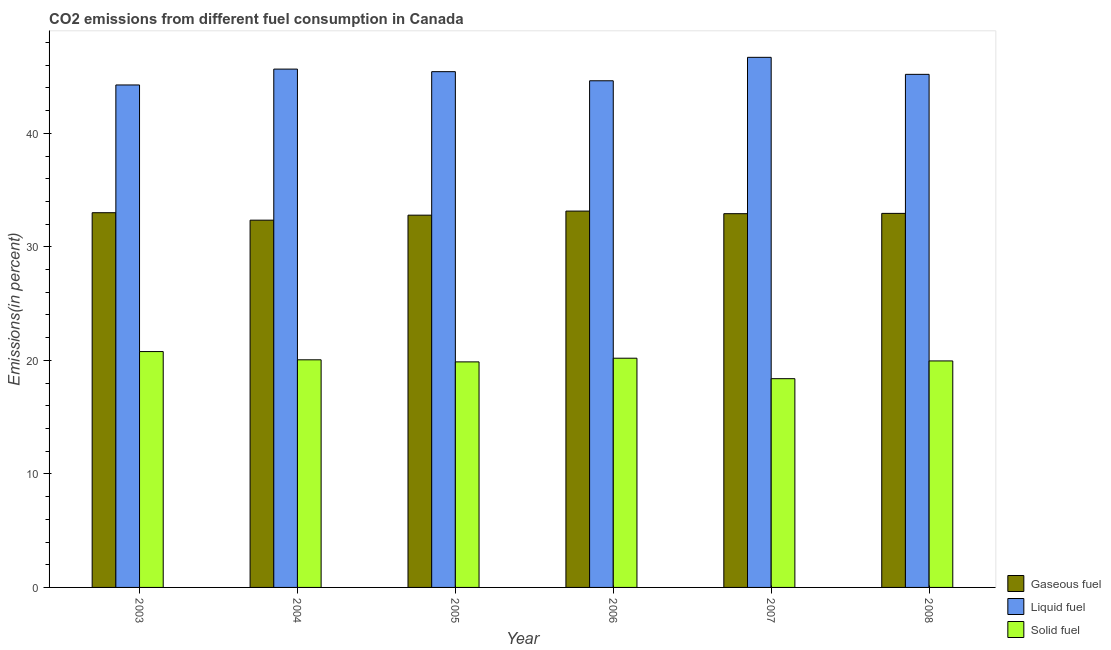How many groups of bars are there?
Ensure brevity in your answer.  6. How many bars are there on the 4th tick from the right?
Your answer should be compact. 3. What is the label of the 3rd group of bars from the left?
Ensure brevity in your answer.  2005. In how many cases, is the number of bars for a given year not equal to the number of legend labels?
Keep it short and to the point. 0. What is the percentage of liquid fuel emission in 2006?
Keep it short and to the point. 44.63. Across all years, what is the maximum percentage of liquid fuel emission?
Your answer should be compact. 46.7. Across all years, what is the minimum percentage of liquid fuel emission?
Your answer should be very brief. 44.26. In which year was the percentage of solid fuel emission minimum?
Your response must be concise. 2007. What is the total percentage of solid fuel emission in the graph?
Ensure brevity in your answer.  119.23. What is the difference between the percentage of gaseous fuel emission in 2007 and that in 2008?
Make the answer very short. -0.03. What is the difference between the percentage of liquid fuel emission in 2008 and the percentage of solid fuel emission in 2005?
Provide a succinct answer. -0.24. What is the average percentage of liquid fuel emission per year?
Your response must be concise. 45.32. What is the ratio of the percentage of liquid fuel emission in 2006 to that in 2007?
Give a very brief answer. 0.96. Is the percentage of liquid fuel emission in 2006 less than that in 2008?
Offer a very short reply. Yes. What is the difference between the highest and the second highest percentage of solid fuel emission?
Your answer should be very brief. 0.58. What is the difference between the highest and the lowest percentage of gaseous fuel emission?
Your answer should be very brief. 0.8. Is the sum of the percentage of liquid fuel emission in 2007 and 2008 greater than the maximum percentage of solid fuel emission across all years?
Offer a terse response. Yes. What does the 2nd bar from the left in 2004 represents?
Your answer should be compact. Liquid fuel. What does the 2nd bar from the right in 2006 represents?
Provide a short and direct response. Liquid fuel. Is it the case that in every year, the sum of the percentage of gaseous fuel emission and percentage of liquid fuel emission is greater than the percentage of solid fuel emission?
Give a very brief answer. Yes. Are all the bars in the graph horizontal?
Keep it short and to the point. No. Where does the legend appear in the graph?
Your response must be concise. Bottom right. How are the legend labels stacked?
Keep it short and to the point. Vertical. What is the title of the graph?
Give a very brief answer. CO2 emissions from different fuel consumption in Canada. Does "Social Protection" appear as one of the legend labels in the graph?
Your answer should be compact. No. What is the label or title of the Y-axis?
Offer a terse response. Emissions(in percent). What is the Emissions(in percent) in Gaseous fuel in 2003?
Give a very brief answer. 33.01. What is the Emissions(in percent) in Liquid fuel in 2003?
Provide a short and direct response. 44.26. What is the Emissions(in percent) of Solid fuel in 2003?
Ensure brevity in your answer.  20.78. What is the Emissions(in percent) in Gaseous fuel in 2004?
Offer a terse response. 32.35. What is the Emissions(in percent) in Liquid fuel in 2004?
Make the answer very short. 45.66. What is the Emissions(in percent) of Solid fuel in 2004?
Keep it short and to the point. 20.05. What is the Emissions(in percent) in Gaseous fuel in 2005?
Offer a terse response. 32.79. What is the Emissions(in percent) in Liquid fuel in 2005?
Give a very brief answer. 45.44. What is the Emissions(in percent) in Solid fuel in 2005?
Keep it short and to the point. 19.87. What is the Emissions(in percent) of Gaseous fuel in 2006?
Your answer should be compact. 33.15. What is the Emissions(in percent) in Liquid fuel in 2006?
Your answer should be very brief. 44.63. What is the Emissions(in percent) in Solid fuel in 2006?
Your answer should be very brief. 20.19. What is the Emissions(in percent) in Gaseous fuel in 2007?
Ensure brevity in your answer.  32.92. What is the Emissions(in percent) of Liquid fuel in 2007?
Your response must be concise. 46.7. What is the Emissions(in percent) of Solid fuel in 2007?
Your answer should be compact. 18.39. What is the Emissions(in percent) in Gaseous fuel in 2008?
Provide a succinct answer. 32.95. What is the Emissions(in percent) in Liquid fuel in 2008?
Your response must be concise. 45.2. What is the Emissions(in percent) of Solid fuel in 2008?
Make the answer very short. 19.95. Across all years, what is the maximum Emissions(in percent) of Gaseous fuel?
Your answer should be very brief. 33.15. Across all years, what is the maximum Emissions(in percent) in Liquid fuel?
Your answer should be very brief. 46.7. Across all years, what is the maximum Emissions(in percent) in Solid fuel?
Offer a terse response. 20.78. Across all years, what is the minimum Emissions(in percent) of Gaseous fuel?
Make the answer very short. 32.35. Across all years, what is the minimum Emissions(in percent) of Liquid fuel?
Your answer should be compact. 44.26. Across all years, what is the minimum Emissions(in percent) of Solid fuel?
Provide a succinct answer. 18.39. What is the total Emissions(in percent) in Gaseous fuel in the graph?
Provide a short and direct response. 197.19. What is the total Emissions(in percent) of Liquid fuel in the graph?
Your answer should be very brief. 271.89. What is the total Emissions(in percent) of Solid fuel in the graph?
Make the answer very short. 119.23. What is the difference between the Emissions(in percent) of Gaseous fuel in 2003 and that in 2004?
Offer a very short reply. 0.66. What is the difference between the Emissions(in percent) of Liquid fuel in 2003 and that in 2004?
Provide a succinct answer. -1.4. What is the difference between the Emissions(in percent) of Solid fuel in 2003 and that in 2004?
Provide a short and direct response. 0.73. What is the difference between the Emissions(in percent) of Gaseous fuel in 2003 and that in 2005?
Offer a very short reply. 0.22. What is the difference between the Emissions(in percent) of Liquid fuel in 2003 and that in 2005?
Your response must be concise. -1.17. What is the difference between the Emissions(in percent) in Solid fuel in 2003 and that in 2005?
Offer a very short reply. 0.91. What is the difference between the Emissions(in percent) in Gaseous fuel in 2003 and that in 2006?
Your response must be concise. -0.14. What is the difference between the Emissions(in percent) of Liquid fuel in 2003 and that in 2006?
Give a very brief answer. -0.37. What is the difference between the Emissions(in percent) in Solid fuel in 2003 and that in 2006?
Offer a terse response. 0.58. What is the difference between the Emissions(in percent) of Gaseous fuel in 2003 and that in 2007?
Your answer should be compact. 0.09. What is the difference between the Emissions(in percent) of Liquid fuel in 2003 and that in 2007?
Provide a short and direct response. -2.43. What is the difference between the Emissions(in percent) in Solid fuel in 2003 and that in 2007?
Ensure brevity in your answer.  2.39. What is the difference between the Emissions(in percent) of Gaseous fuel in 2003 and that in 2008?
Offer a very short reply. 0.06. What is the difference between the Emissions(in percent) in Liquid fuel in 2003 and that in 2008?
Provide a short and direct response. -0.93. What is the difference between the Emissions(in percent) of Solid fuel in 2003 and that in 2008?
Offer a terse response. 0.82. What is the difference between the Emissions(in percent) in Gaseous fuel in 2004 and that in 2005?
Make the answer very short. -0.44. What is the difference between the Emissions(in percent) of Liquid fuel in 2004 and that in 2005?
Your response must be concise. 0.23. What is the difference between the Emissions(in percent) in Solid fuel in 2004 and that in 2005?
Ensure brevity in your answer.  0.18. What is the difference between the Emissions(in percent) of Gaseous fuel in 2004 and that in 2006?
Your answer should be compact. -0.8. What is the difference between the Emissions(in percent) in Liquid fuel in 2004 and that in 2006?
Your response must be concise. 1.03. What is the difference between the Emissions(in percent) of Solid fuel in 2004 and that in 2006?
Your answer should be compact. -0.14. What is the difference between the Emissions(in percent) of Gaseous fuel in 2004 and that in 2007?
Keep it short and to the point. -0.57. What is the difference between the Emissions(in percent) of Liquid fuel in 2004 and that in 2007?
Your answer should be very brief. -1.04. What is the difference between the Emissions(in percent) in Solid fuel in 2004 and that in 2007?
Your answer should be compact. 1.66. What is the difference between the Emissions(in percent) in Gaseous fuel in 2004 and that in 2008?
Keep it short and to the point. -0.6. What is the difference between the Emissions(in percent) of Liquid fuel in 2004 and that in 2008?
Offer a very short reply. 0.46. What is the difference between the Emissions(in percent) of Solid fuel in 2004 and that in 2008?
Your response must be concise. 0.1. What is the difference between the Emissions(in percent) in Gaseous fuel in 2005 and that in 2006?
Provide a succinct answer. -0.36. What is the difference between the Emissions(in percent) of Liquid fuel in 2005 and that in 2006?
Keep it short and to the point. 0.8. What is the difference between the Emissions(in percent) in Solid fuel in 2005 and that in 2006?
Offer a very short reply. -0.32. What is the difference between the Emissions(in percent) of Gaseous fuel in 2005 and that in 2007?
Ensure brevity in your answer.  -0.13. What is the difference between the Emissions(in percent) in Liquid fuel in 2005 and that in 2007?
Provide a short and direct response. -1.26. What is the difference between the Emissions(in percent) in Solid fuel in 2005 and that in 2007?
Offer a terse response. 1.48. What is the difference between the Emissions(in percent) in Gaseous fuel in 2005 and that in 2008?
Give a very brief answer. -0.16. What is the difference between the Emissions(in percent) in Liquid fuel in 2005 and that in 2008?
Your answer should be very brief. 0.24. What is the difference between the Emissions(in percent) in Solid fuel in 2005 and that in 2008?
Give a very brief answer. -0.08. What is the difference between the Emissions(in percent) of Gaseous fuel in 2006 and that in 2007?
Ensure brevity in your answer.  0.23. What is the difference between the Emissions(in percent) of Liquid fuel in 2006 and that in 2007?
Make the answer very short. -2.07. What is the difference between the Emissions(in percent) of Solid fuel in 2006 and that in 2007?
Your answer should be very brief. 1.8. What is the difference between the Emissions(in percent) in Gaseous fuel in 2006 and that in 2008?
Make the answer very short. 0.2. What is the difference between the Emissions(in percent) in Liquid fuel in 2006 and that in 2008?
Ensure brevity in your answer.  -0.57. What is the difference between the Emissions(in percent) of Solid fuel in 2006 and that in 2008?
Offer a very short reply. 0.24. What is the difference between the Emissions(in percent) in Gaseous fuel in 2007 and that in 2008?
Your answer should be compact. -0.03. What is the difference between the Emissions(in percent) of Liquid fuel in 2007 and that in 2008?
Your answer should be very brief. 1.5. What is the difference between the Emissions(in percent) in Solid fuel in 2007 and that in 2008?
Offer a very short reply. -1.56. What is the difference between the Emissions(in percent) in Gaseous fuel in 2003 and the Emissions(in percent) in Liquid fuel in 2004?
Make the answer very short. -12.65. What is the difference between the Emissions(in percent) of Gaseous fuel in 2003 and the Emissions(in percent) of Solid fuel in 2004?
Provide a short and direct response. 12.96. What is the difference between the Emissions(in percent) in Liquid fuel in 2003 and the Emissions(in percent) in Solid fuel in 2004?
Offer a terse response. 24.21. What is the difference between the Emissions(in percent) in Gaseous fuel in 2003 and the Emissions(in percent) in Liquid fuel in 2005?
Make the answer very short. -12.43. What is the difference between the Emissions(in percent) of Gaseous fuel in 2003 and the Emissions(in percent) of Solid fuel in 2005?
Make the answer very short. 13.14. What is the difference between the Emissions(in percent) of Liquid fuel in 2003 and the Emissions(in percent) of Solid fuel in 2005?
Ensure brevity in your answer.  24.4. What is the difference between the Emissions(in percent) of Gaseous fuel in 2003 and the Emissions(in percent) of Liquid fuel in 2006?
Ensure brevity in your answer.  -11.62. What is the difference between the Emissions(in percent) in Gaseous fuel in 2003 and the Emissions(in percent) in Solid fuel in 2006?
Provide a short and direct response. 12.82. What is the difference between the Emissions(in percent) of Liquid fuel in 2003 and the Emissions(in percent) of Solid fuel in 2006?
Your response must be concise. 24.07. What is the difference between the Emissions(in percent) in Gaseous fuel in 2003 and the Emissions(in percent) in Liquid fuel in 2007?
Offer a terse response. -13.69. What is the difference between the Emissions(in percent) in Gaseous fuel in 2003 and the Emissions(in percent) in Solid fuel in 2007?
Your answer should be compact. 14.62. What is the difference between the Emissions(in percent) of Liquid fuel in 2003 and the Emissions(in percent) of Solid fuel in 2007?
Provide a succinct answer. 25.88. What is the difference between the Emissions(in percent) in Gaseous fuel in 2003 and the Emissions(in percent) in Liquid fuel in 2008?
Provide a short and direct response. -12.19. What is the difference between the Emissions(in percent) of Gaseous fuel in 2003 and the Emissions(in percent) of Solid fuel in 2008?
Provide a short and direct response. 13.06. What is the difference between the Emissions(in percent) of Liquid fuel in 2003 and the Emissions(in percent) of Solid fuel in 2008?
Make the answer very short. 24.31. What is the difference between the Emissions(in percent) in Gaseous fuel in 2004 and the Emissions(in percent) in Liquid fuel in 2005?
Offer a very short reply. -13.08. What is the difference between the Emissions(in percent) in Gaseous fuel in 2004 and the Emissions(in percent) in Solid fuel in 2005?
Give a very brief answer. 12.48. What is the difference between the Emissions(in percent) of Liquid fuel in 2004 and the Emissions(in percent) of Solid fuel in 2005?
Give a very brief answer. 25.79. What is the difference between the Emissions(in percent) of Gaseous fuel in 2004 and the Emissions(in percent) of Liquid fuel in 2006?
Provide a short and direct response. -12.28. What is the difference between the Emissions(in percent) of Gaseous fuel in 2004 and the Emissions(in percent) of Solid fuel in 2006?
Keep it short and to the point. 12.16. What is the difference between the Emissions(in percent) in Liquid fuel in 2004 and the Emissions(in percent) in Solid fuel in 2006?
Keep it short and to the point. 25.47. What is the difference between the Emissions(in percent) in Gaseous fuel in 2004 and the Emissions(in percent) in Liquid fuel in 2007?
Your answer should be compact. -14.35. What is the difference between the Emissions(in percent) in Gaseous fuel in 2004 and the Emissions(in percent) in Solid fuel in 2007?
Make the answer very short. 13.96. What is the difference between the Emissions(in percent) of Liquid fuel in 2004 and the Emissions(in percent) of Solid fuel in 2007?
Your answer should be compact. 27.27. What is the difference between the Emissions(in percent) in Gaseous fuel in 2004 and the Emissions(in percent) in Liquid fuel in 2008?
Your answer should be very brief. -12.85. What is the difference between the Emissions(in percent) of Gaseous fuel in 2004 and the Emissions(in percent) of Solid fuel in 2008?
Give a very brief answer. 12.4. What is the difference between the Emissions(in percent) of Liquid fuel in 2004 and the Emissions(in percent) of Solid fuel in 2008?
Your response must be concise. 25.71. What is the difference between the Emissions(in percent) of Gaseous fuel in 2005 and the Emissions(in percent) of Liquid fuel in 2006?
Give a very brief answer. -11.84. What is the difference between the Emissions(in percent) in Gaseous fuel in 2005 and the Emissions(in percent) in Solid fuel in 2006?
Offer a terse response. 12.6. What is the difference between the Emissions(in percent) in Liquid fuel in 2005 and the Emissions(in percent) in Solid fuel in 2006?
Your answer should be very brief. 25.24. What is the difference between the Emissions(in percent) in Gaseous fuel in 2005 and the Emissions(in percent) in Liquid fuel in 2007?
Your answer should be very brief. -13.9. What is the difference between the Emissions(in percent) in Gaseous fuel in 2005 and the Emissions(in percent) in Solid fuel in 2007?
Ensure brevity in your answer.  14.41. What is the difference between the Emissions(in percent) of Liquid fuel in 2005 and the Emissions(in percent) of Solid fuel in 2007?
Offer a very short reply. 27.05. What is the difference between the Emissions(in percent) in Gaseous fuel in 2005 and the Emissions(in percent) in Liquid fuel in 2008?
Ensure brevity in your answer.  -12.4. What is the difference between the Emissions(in percent) of Gaseous fuel in 2005 and the Emissions(in percent) of Solid fuel in 2008?
Your answer should be compact. 12.84. What is the difference between the Emissions(in percent) of Liquid fuel in 2005 and the Emissions(in percent) of Solid fuel in 2008?
Provide a short and direct response. 25.48. What is the difference between the Emissions(in percent) of Gaseous fuel in 2006 and the Emissions(in percent) of Liquid fuel in 2007?
Offer a very short reply. -13.55. What is the difference between the Emissions(in percent) of Gaseous fuel in 2006 and the Emissions(in percent) of Solid fuel in 2007?
Your answer should be compact. 14.76. What is the difference between the Emissions(in percent) of Liquid fuel in 2006 and the Emissions(in percent) of Solid fuel in 2007?
Keep it short and to the point. 26.24. What is the difference between the Emissions(in percent) in Gaseous fuel in 2006 and the Emissions(in percent) in Liquid fuel in 2008?
Keep it short and to the point. -12.05. What is the difference between the Emissions(in percent) in Gaseous fuel in 2006 and the Emissions(in percent) in Solid fuel in 2008?
Offer a very short reply. 13.2. What is the difference between the Emissions(in percent) of Liquid fuel in 2006 and the Emissions(in percent) of Solid fuel in 2008?
Offer a very short reply. 24.68. What is the difference between the Emissions(in percent) of Gaseous fuel in 2007 and the Emissions(in percent) of Liquid fuel in 2008?
Your response must be concise. -12.27. What is the difference between the Emissions(in percent) in Gaseous fuel in 2007 and the Emissions(in percent) in Solid fuel in 2008?
Offer a terse response. 12.97. What is the difference between the Emissions(in percent) of Liquid fuel in 2007 and the Emissions(in percent) of Solid fuel in 2008?
Give a very brief answer. 26.74. What is the average Emissions(in percent) in Gaseous fuel per year?
Offer a very short reply. 32.86. What is the average Emissions(in percent) of Liquid fuel per year?
Offer a very short reply. 45.32. What is the average Emissions(in percent) of Solid fuel per year?
Your answer should be compact. 19.87. In the year 2003, what is the difference between the Emissions(in percent) of Gaseous fuel and Emissions(in percent) of Liquid fuel?
Provide a short and direct response. -11.25. In the year 2003, what is the difference between the Emissions(in percent) of Gaseous fuel and Emissions(in percent) of Solid fuel?
Your answer should be very brief. 12.23. In the year 2003, what is the difference between the Emissions(in percent) in Liquid fuel and Emissions(in percent) in Solid fuel?
Your answer should be very brief. 23.49. In the year 2004, what is the difference between the Emissions(in percent) of Gaseous fuel and Emissions(in percent) of Liquid fuel?
Your answer should be very brief. -13.31. In the year 2004, what is the difference between the Emissions(in percent) of Gaseous fuel and Emissions(in percent) of Solid fuel?
Offer a very short reply. 12.3. In the year 2004, what is the difference between the Emissions(in percent) in Liquid fuel and Emissions(in percent) in Solid fuel?
Provide a short and direct response. 25.61. In the year 2005, what is the difference between the Emissions(in percent) of Gaseous fuel and Emissions(in percent) of Liquid fuel?
Keep it short and to the point. -12.64. In the year 2005, what is the difference between the Emissions(in percent) of Gaseous fuel and Emissions(in percent) of Solid fuel?
Your response must be concise. 12.93. In the year 2005, what is the difference between the Emissions(in percent) of Liquid fuel and Emissions(in percent) of Solid fuel?
Ensure brevity in your answer.  25.57. In the year 2006, what is the difference between the Emissions(in percent) in Gaseous fuel and Emissions(in percent) in Liquid fuel?
Offer a terse response. -11.48. In the year 2006, what is the difference between the Emissions(in percent) of Gaseous fuel and Emissions(in percent) of Solid fuel?
Offer a very short reply. 12.96. In the year 2006, what is the difference between the Emissions(in percent) in Liquid fuel and Emissions(in percent) in Solid fuel?
Ensure brevity in your answer.  24.44. In the year 2007, what is the difference between the Emissions(in percent) of Gaseous fuel and Emissions(in percent) of Liquid fuel?
Keep it short and to the point. -13.77. In the year 2007, what is the difference between the Emissions(in percent) in Gaseous fuel and Emissions(in percent) in Solid fuel?
Give a very brief answer. 14.54. In the year 2007, what is the difference between the Emissions(in percent) in Liquid fuel and Emissions(in percent) in Solid fuel?
Your response must be concise. 28.31. In the year 2008, what is the difference between the Emissions(in percent) of Gaseous fuel and Emissions(in percent) of Liquid fuel?
Give a very brief answer. -12.25. In the year 2008, what is the difference between the Emissions(in percent) of Gaseous fuel and Emissions(in percent) of Solid fuel?
Provide a succinct answer. 13. In the year 2008, what is the difference between the Emissions(in percent) of Liquid fuel and Emissions(in percent) of Solid fuel?
Offer a very short reply. 25.24. What is the ratio of the Emissions(in percent) in Gaseous fuel in 2003 to that in 2004?
Provide a succinct answer. 1.02. What is the ratio of the Emissions(in percent) in Liquid fuel in 2003 to that in 2004?
Give a very brief answer. 0.97. What is the ratio of the Emissions(in percent) of Solid fuel in 2003 to that in 2004?
Ensure brevity in your answer.  1.04. What is the ratio of the Emissions(in percent) of Gaseous fuel in 2003 to that in 2005?
Give a very brief answer. 1.01. What is the ratio of the Emissions(in percent) in Liquid fuel in 2003 to that in 2005?
Offer a terse response. 0.97. What is the ratio of the Emissions(in percent) of Solid fuel in 2003 to that in 2005?
Your response must be concise. 1.05. What is the ratio of the Emissions(in percent) of Gaseous fuel in 2003 to that in 2006?
Offer a very short reply. 1. What is the ratio of the Emissions(in percent) of Liquid fuel in 2003 to that in 2006?
Offer a very short reply. 0.99. What is the ratio of the Emissions(in percent) in Solid fuel in 2003 to that in 2006?
Keep it short and to the point. 1.03. What is the ratio of the Emissions(in percent) of Liquid fuel in 2003 to that in 2007?
Provide a succinct answer. 0.95. What is the ratio of the Emissions(in percent) of Solid fuel in 2003 to that in 2007?
Your response must be concise. 1.13. What is the ratio of the Emissions(in percent) of Gaseous fuel in 2003 to that in 2008?
Make the answer very short. 1. What is the ratio of the Emissions(in percent) of Liquid fuel in 2003 to that in 2008?
Offer a very short reply. 0.98. What is the ratio of the Emissions(in percent) of Solid fuel in 2003 to that in 2008?
Keep it short and to the point. 1.04. What is the ratio of the Emissions(in percent) in Gaseous fuel in 2004 to that in 2005?
Your response must be concise. 0.99. What is the ratio of the Emissions(in percent) in Solid fuel in 2004 to that in 2005?
Your answer should be compact. 1.01. What is the ratio of the Emissions(in percent) of Gaseous fuel in 2004 to that in 2006?
Provide a succinct answer. 0.98. What is the ratio of the Emissions(in percent) in Liquid fuel in 2004 to that in 2006?
Make the answer very short. 1.02. What is the ratio of the Emissions(in percent) in Solid fuel in 2004 to that in 2006?
Offer a very short reply. 0.99. What is the ratio of the Emissions(in percent) in Gaseous fuel in 2004 to that in 2007?
Provide a short and direct response. 0.98. What is the ratio of the Emissions(in percent) in Liquid fuel in 2004 to that in 2007?
Your answer should be compact. 0.98. What is the ratio of the Emissions(in percent) in Solid fuel in 2004 to that in 2007?
Your answer should be very brief. 1.09. What is the ratio of the Emissions(in percent) of Gaseous fuel in 2004 to that in 2008?
Offer a very short reply. 0.98. What is the ratio of the Emissions(in percent) of Liquid fuel in 2004 to that in 2008?
Ensure brevity in your answer.  1.01. What is the ratio of the Emissions(in percent) of Gaseous fuel in 2005 to that in 2006?
Give a very brief answer. 0.99. What is the ratio of the Emissions(in percent) of Liquid fuel in 2005 to that in 2006?
Keep it short and to the point. 1.02. What is the ratio of the Emissions(in percent) of Solid fuel in 2005 to that in 2006?
Provide a succinct answer. 0.98. What is the ratio of the Emissions(in percent) in Gaseous fuel in 2005 to that in 2007?
Provide a succinct answer. 1. What is the ratio of the Emissions(in percent) in Solid fuel in 2005 to that in 2007?
Ensure brevity in your answer.  1.08. What is the ratio of the Emissions(in percent) of Gaseous fuel in 2005 to that in 2008?
Your response must be concise. 1. What is the ratio of the Emissions(in percent) in Liquid fuel in 2005 to that in 2008?
Provide a short and direct response. 1.01. What is the ratio of the Emissions(in percent) in Solid fuel in 2005 to that in 2008?
Make the answer very short. 1. What is the ratio of the Emissions(in percent) of Liquid fuel in 2006 to that in 2007?
Offer a terse response. 0.96. What is the ratio of the Emissions(in percent) of Solid fuel in 2006 to that in 2007?
Give a very brief answer. 1.1. What is the ratio of the Emissions(in percent) in Liquid fuel in 2006 to that in 2008?
Give a very brief answer. 0.99. What is the ratio of the Emissions(in percent) of Gaseous fuel in 2007 to that in 2008?
Your answer should be compact. 1. What is the ratio of the Emissions(in percent) of Liquid fuel in 2007 to that in 2008?
Offer a very short reply. 1.03. What is the ratio of the Emissions(in percent) in Solid fuel in 2007 to that in 2008?
Your answer should be compact. 0.92. What is the difference between the highest and the second highest Emissions(in percent) in Gaseous fuel?
Your answer should be very brief. 0.14. What is the difference between the highest and the second highest Emissions(in percent) of Liquid fuel?
Provide a short and direct response. 1.04. What is the difference between the highest and the second highest Emissions(in percent) of Solid fuel?
Keep it short and to the point. 0.58. What is the difference between the highest and the lowest Emissions(in percent) in Gaseous fuel?
Provide a succinct answer. 0.8. What is the difference between the highest and the lowest Emissions(in percent) of Liquid fuel?
Ensure brevity in your answer.  2.43. What is the difference between the highest and the lowest Emissions(in percent) in Solid fuel?
Offer a very short reply. 2.39. 